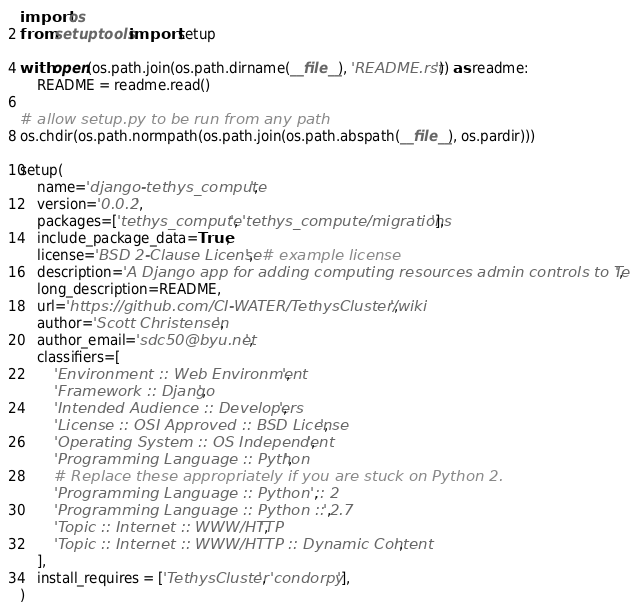Convert code to text. <code><loc_0><loc_0><loc_500><loc_500><_Python_>import os
from setuptools import setup

with open(os.path.join(os.path.dirname(__file__), 'README.rst')) as readme:
    README = readme.read()

# allow setup.py to be run from any path
os.chdir(os.path.normpath(os.path.join(os.path.abspath(__file__), os.pardir)))

setup(
    name='django-tethys_compute',
    version='0.0.2',
    packages=['tethys_compute', 'tethys_compute/migrations'],
    include_package_data=True,
    license='BSD 2-Clause License',  # example license
    description='A Django app for adding computing resources admin controls to Tethys .',
    long_description=README,
    url='https://github.com/CI-WATER/TethysCluster/wiki',
    author='Scott Christensen',
    author_email='sdc50@byu.net',
    classifiers=[
        'Environment :: Web Environment',
        'Framework :: Django',
        'Intended Audience :: Developers',
        'License :: OSI Approved :: BSD License',
        'Operating System :: OS Independent',
        'Programming Language :: Python',
        # Replace these appropriately if you are stuck on Python 2.
        'Programming Language :: Python :: 2',
        'Programming Language :: Python :: 2.7',
        'Topic :: Internet :: WWW/HTTP',
        'Topic :: Internet :: WWW/HTTP :: Dynamic Content',
    ],
    install_requires = ['TethysCluster', 'condorpy'],
)</code> 